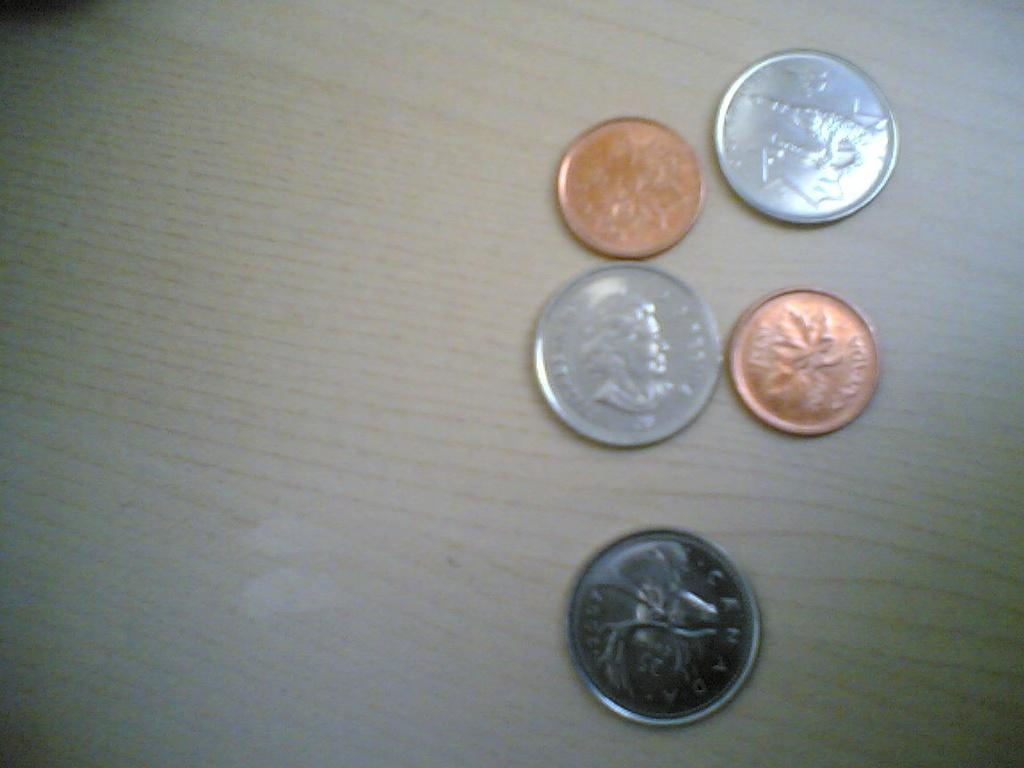<image>
Relay a brief, clear account of the picture shown. A collection of coins, at least one of which is Canadian. 